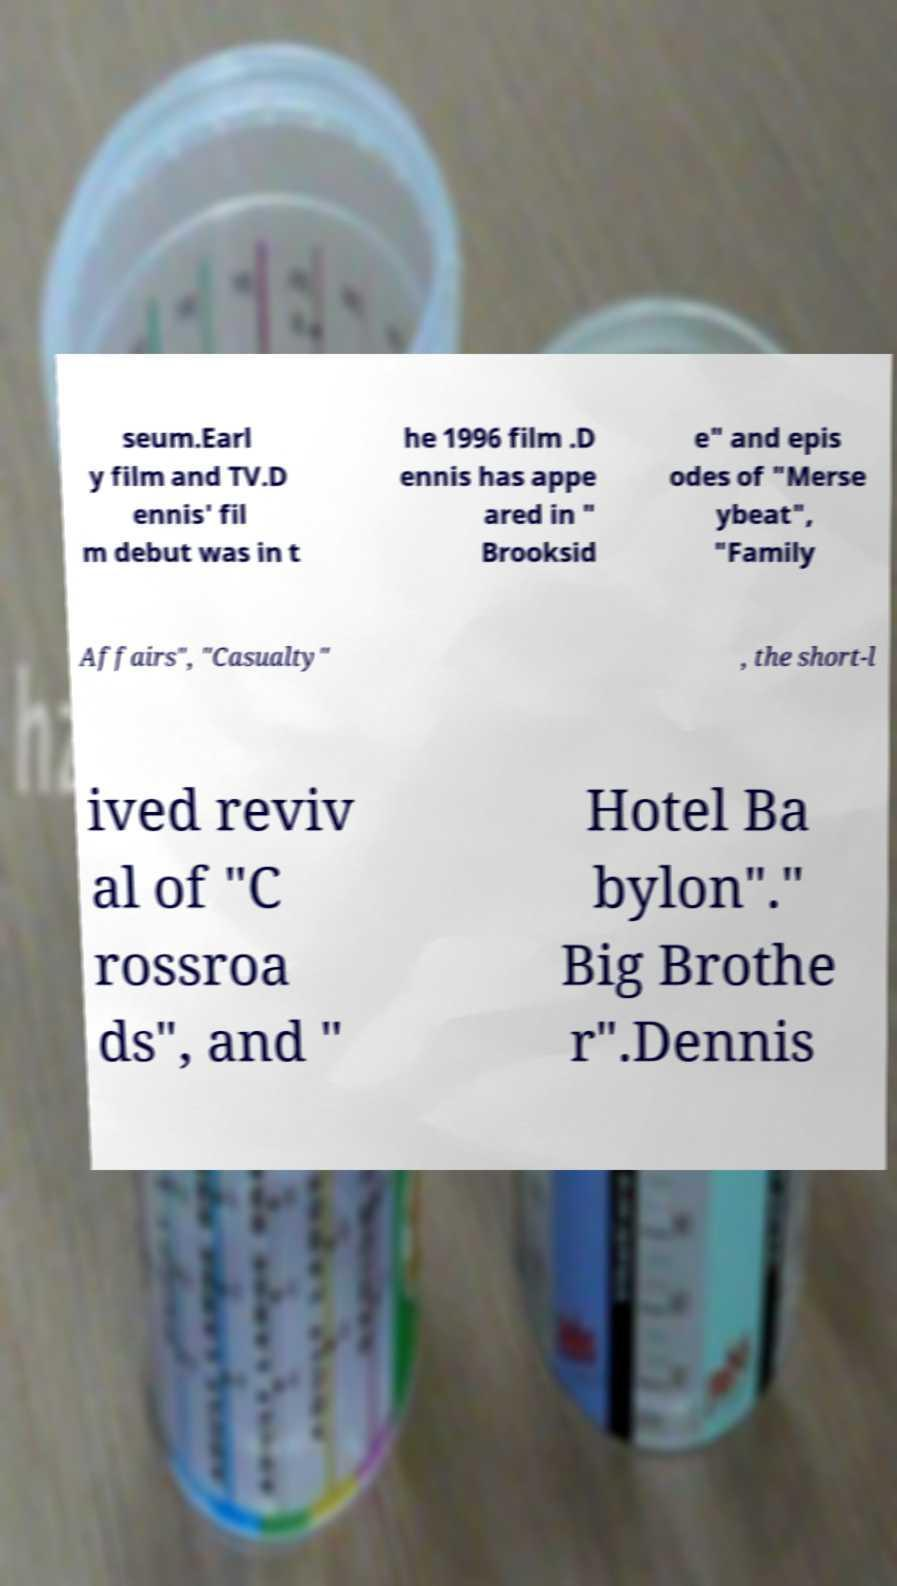I need the written content from this picture converted into text. Can you do that? seum.Earl y film and TV.D ennis' fil m debut was in t he 1996 film .D ennis has appe ared in " Brooksid e" and epis odes of "Merse ybeat", "Family Affairs", "Casualty" , the short-l ived reviv al of "C rossroa ds", and " Hotel Ba bylon"." Big Brothe r".Dennis 